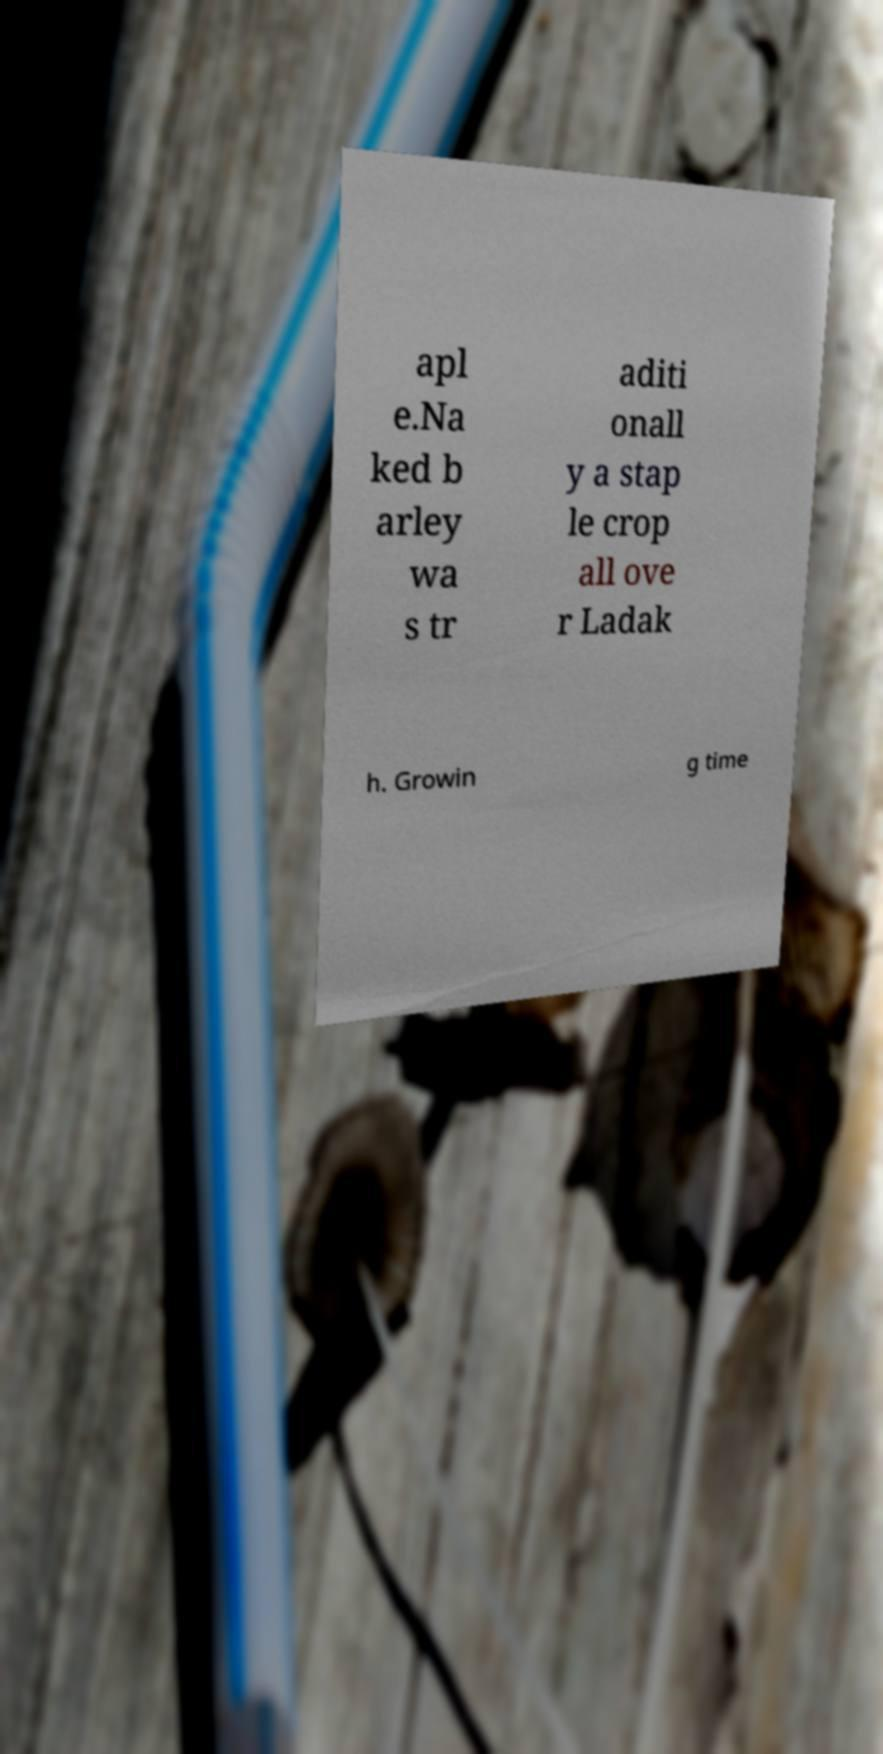What messages or text are displayed in this image? I need them in a readable, typed format. apl e.Na ked b arley wa s tr aditi onall y a stap le crop all ove r Ladak h. Growin g time 